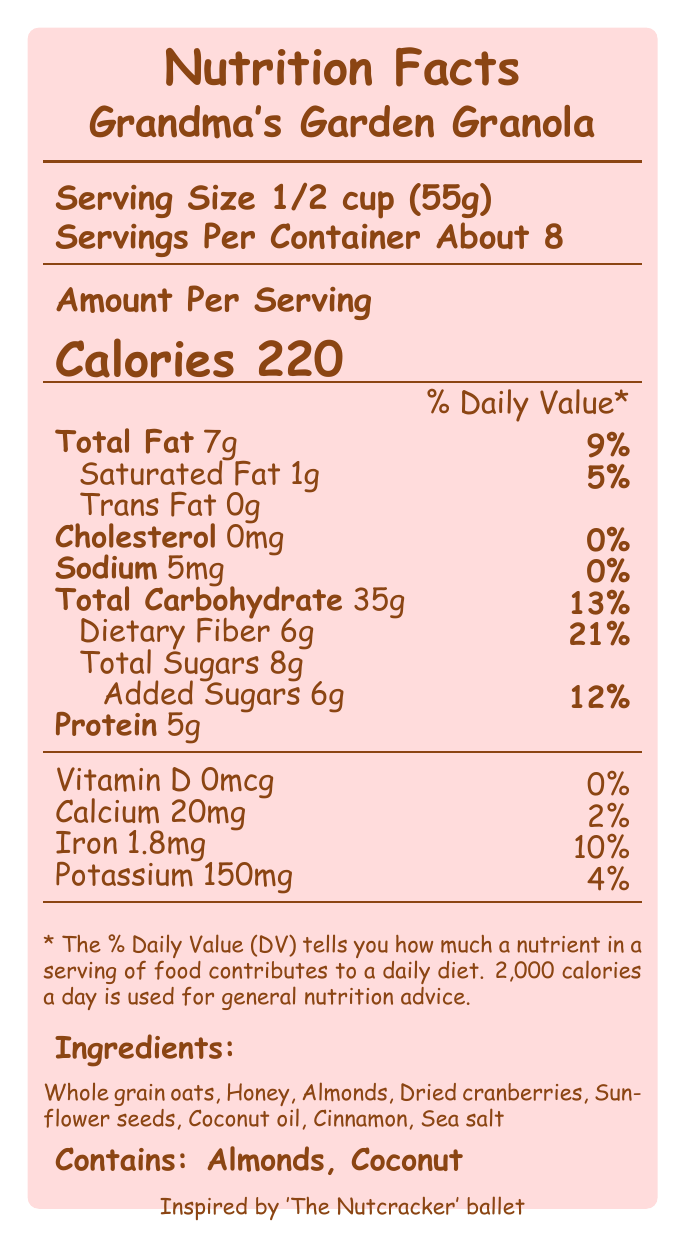what is the serving size? The serving size is clearly stated on the document under the "Serving Size" section.
Answer: 1/2 cup (55g) how many calories are there per serving? The document specifies 220 calories per serving in the "Calories" section.
Answer: 220 what percentage of daily value is the dietary fiber? The dietary fiber daily value percentage is found next to "Dietary Fiber", which is 21%.
Answer: 21% how much saturated fat is in one serving? The amount of saturated fat is listed as 1g in the "Saturated Fat" section.
Answer: 1g does the granola contain any cholesterol? The cholesterol content is listed as 0mg, so the granola contains no cholesterol.
Answer: No which ingredient is a natural sweetener? Among the ingredients listed, honey is a natural sweetener.
Answer: Honey how many grams of protein are in one serving? The protein content per serving is stated as 5g.
Answer: 5g what is the total carbohydrate content in a serving? The document states the total carbohydrate content per serving is 35g.
Answer: 35g what is the total fat daily value percentage? A. 5% B. 9% C. 12% D. 21% The total fat daily value is listed as 9% next to "Total Fat".
Answer: B. 9% how many servings does the container hold? A. About 6 B. About 8 C. About 10 D. About 12 According to the document, there are about 8 servings per container.
Answer: B. About 8 is the granola made with whole grains? The health claims state that the granola is made with whole grains.
Answer: Yes what special features are included in the packaging? Special features are listed at the end, including the recipe inspiration, packaging illustrations, and support for local dance programs.
Answer: Recipe inspired by classic ballet 'The Nutcracker'; packaging features illustrations from children's storybooks; each purchase supports local dance programs for children can you tell the expiration date of the granola from the document? The document does not provide information about the expiration date.
Answer: Not enough information summarize the document The document provides comprehensive nutritional data, ingredient lists, health claims, and special features about "Grandma's Garden Granola".
Answer: The document details the nutrition facts for "Grandma's Garden Granola" with a serving size of 1/2 cup and about 8 servings per container. It provides caloric and nutritional information, including 220 calories per serving, 7g of total fat, 35g of total carbohydrates with 6g of dietary fiber, and 5g of protein. Ingredients include whole grain oats, honey, and more, with potential allergens like almonds and coconut. The product makes several health claims, highlights special packaging features, and supports local dance programs. 